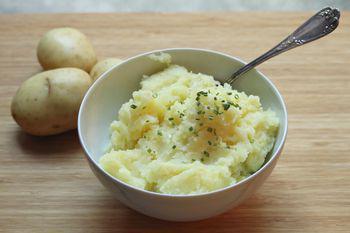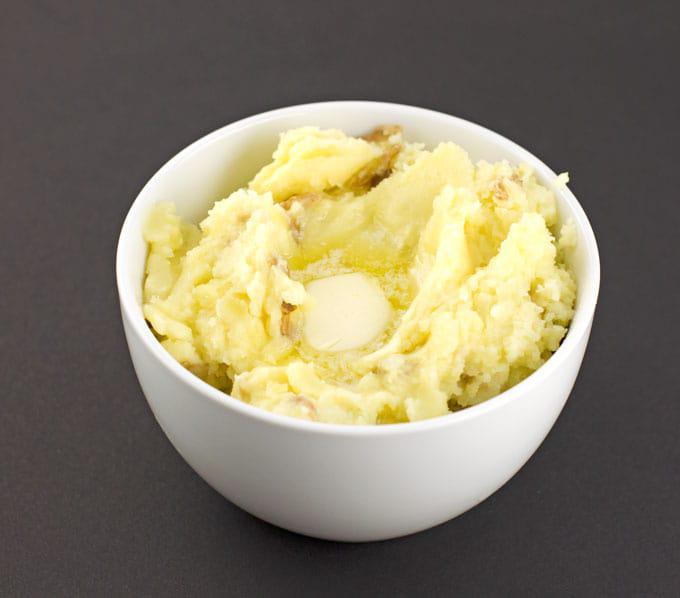The first image is the image on the left, the second image is the image on the right. Assess this claim about the two images: "One image shows mashed potatoes in a squared white dish, with no other food served on the same dish.". Correct or not? Answer yes or no. No. The first image is the image on the left, the second image is the image on the right. Assess this claim about the two images: "One of the images shows  a bowl of mashed potatoes with a spoon in it.". Correct or not? Answer yes or no. Yes. 